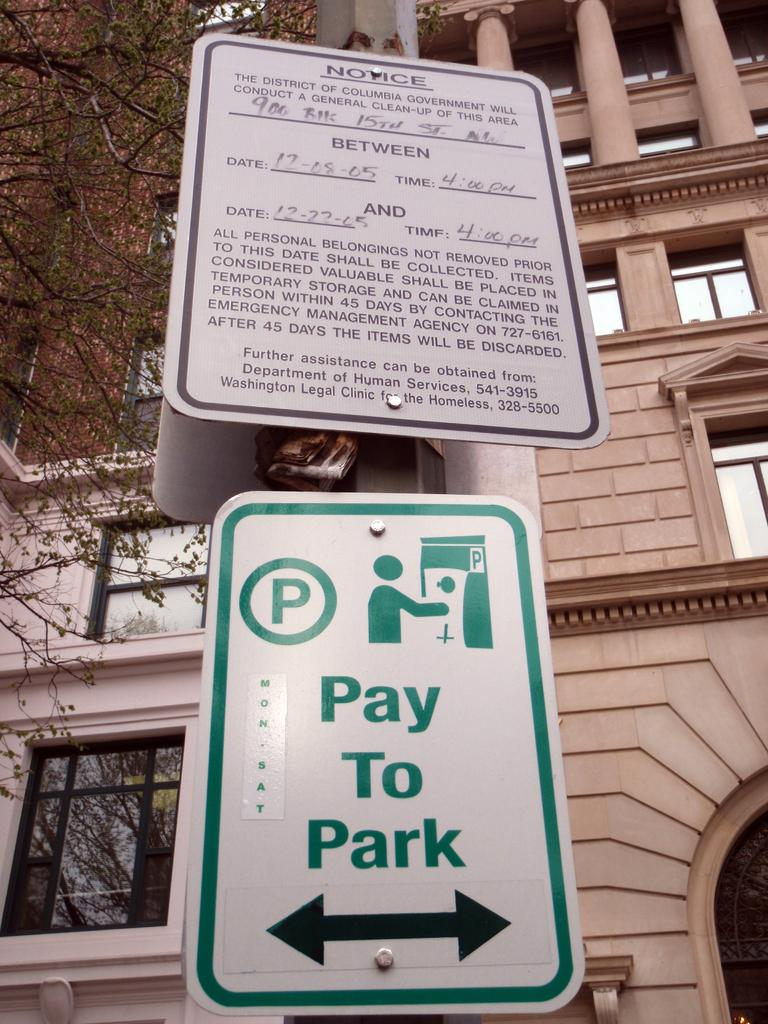Provide a one-sentence caption for the provided image. Notice sign on the side walk that you must pay to park. 